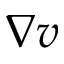Convert formula to latex. <formula><loc_0><loc_0><loc_500><loc_500>\nabla v</formula> 